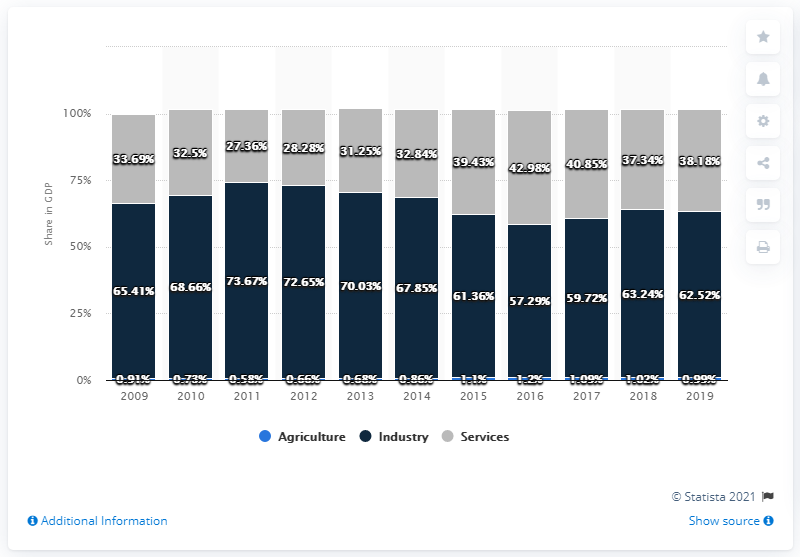Mention a couple of crucial points in this snapshot. The industry sector has a highest percentage of 73.67.. The average of the agriculture sector is 0.89. In 2019, the agriculture sector accounted for 0.99% of Brunei Darussalam's gross domestic product. 